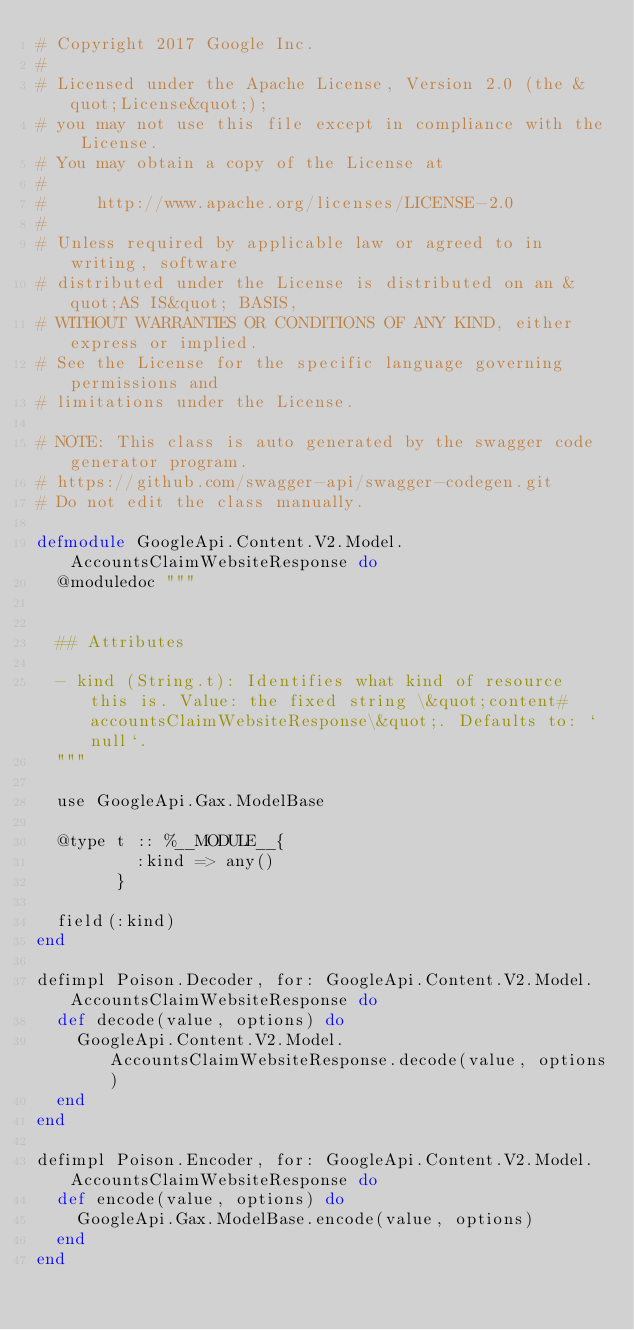<code> <loc_0><loc_0><loc_500><loc_500><_Elixir_># Copyright 2017 Google Inc.
#
# Licensed under the Apache License, Version 2.0 (the &quot;License&quot;);
# you may not use this file except in compliance with the License.
# You may obtain a copy of the License at
#
#     http://www.apache.org/licenses/LICENSE-2.0
#
# Unless required by applicable law or agreed to in writing, software
# distributed under the License is distributed on an &quot;AS IS&quot; BASIS,
# WITHOUT WARRANTIES OR CONDITIONS OF ANY KIND, either express or implied.
# See the License for the specific language governing permissions and
# limitations under the License.

# NOTE: This class is auto generated by the swagger code generator program.
# https://github.com/swagger-api/swagger-codegen.git
# Do not edit the class manually.

defmodule GoogleApi.Content.V2.Model.AccountsClaimWebsiteResponse do
  @moduledoc """


  ## Attributes

  - kind (String.t): Identifies what kind of resource this is. Value: the fixed string \&quot;content#accountsClaimWebsiteResponse\&quot;. Defaults to: `null`.
  """

  use GoogleApi.Gax.ModelBase

  @type t :: %__MODULE__{
          :kind => any()
        }

  field(:kind)
end

defimpl Poison.Decoder, for: GoogleApi.Content.V2.Model.AccountsClaimWebsiteResponse do
  def decode(value, options) do
    GoogleApi.Content.V2.Model.AccountsClaimWebsiteResponse.decode(value, options)
  end
end

defimpl Poison.Encoder, for: GoogleApi.Content.V2.Model.AccountsClaimWebsiteResponse do
  def encode(value, options) do
    GoogleApi.Gax.ModelBase.encode(value, options)
  end
end
</code> 